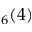Convert formula to latex. <formula><loc_0><loc_0><loc_500><loc_500>_ { 6 } ( 4 )</formula> 